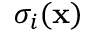Convert formula to latex. <formula><loc_0><loc_0><loc_500><loc_500>\sigma _ { i } ( x )</formula> 